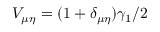Convert formula to latex. <formula><loc_0><loc_0><loc_500><loc_500>V _ { \mu \eta } = ( 1 + \delta _ { \mu \eta } ) \gamma _ { 1 } / 2</formula> 